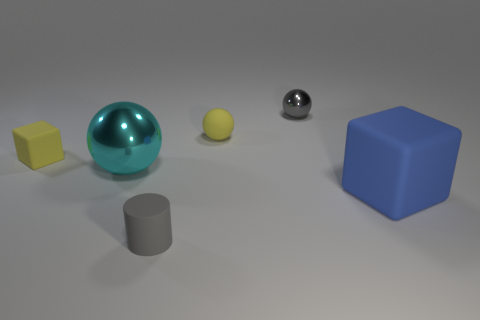Subtract all blue spheres. Subtract all purple cylinders. How many spheres are left? 3 Add 2 big yellow rubber balls. How many objects exist? 8 Subtract all blocks. How many objects are left? 4 Add 4 gray objects. How many gray objects are left? 6 Add 1 small metal objects. How many small metal objects exist? 2 Subtract 0 yellow cylinders. How many objects are left? 6 Subtract all gray rubber things. Subtract all large metal objects. How many objects are left? 4 